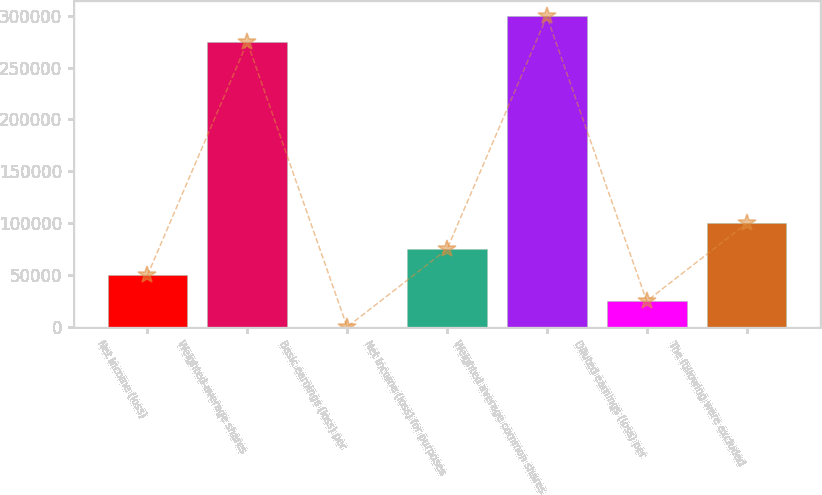Convert chart to OTSL. <chart><loc_0><loc_0><loc_500><loc_500><bar_chart><fcel>Net income (loss)<fcel>Weighted-average shares<fcel>Basic earnings (loss) per<fcel>Net income (loss) for purposes<fcel>Weighted average common shares<fcel>Diluted earnings (loss) per<fcel>The following were excluded<nl><fcel>49904<fcel>274438<fcel>7.52<fcel>74852.3<fcel>299386<fcel>24955.8<fcel>99800.5<nl></chart> 